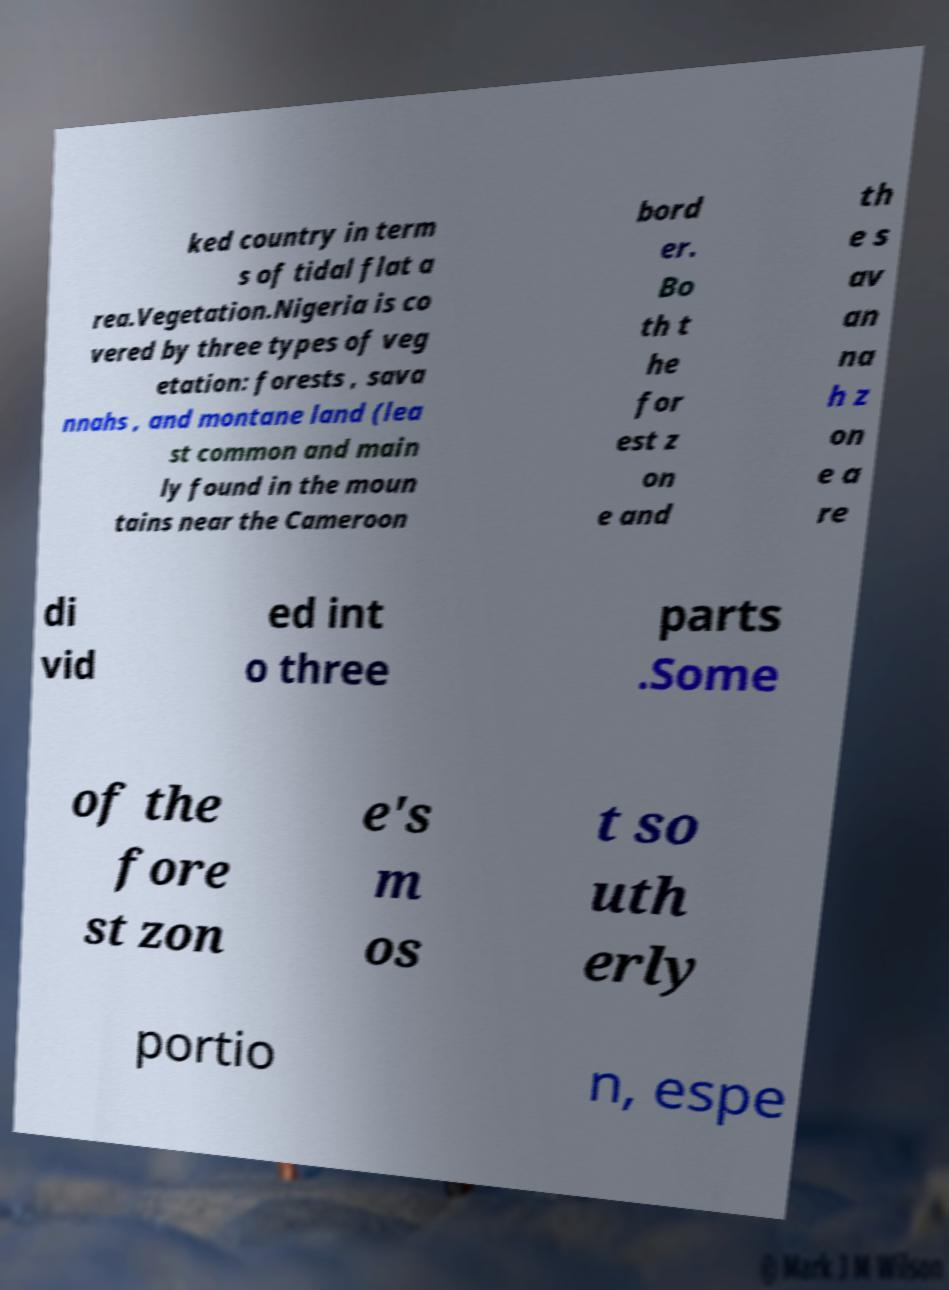For documentation purposes, I need the text within this image transcribed. Could you provide that? ked country in term s of tidal flat a rea.Vegetation.Nigeria is co vered by three types of veg etation: forests , sava nnahs , and montane land (lea st common and main ly found in the moun tains near the Cameroon bord er. Bo th t he for est z on e and th e s av an na h z on e a re di vid ed int o three parts .Some of the fore st zon e's m os t so uth erly portio n, espe 